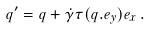Convert formula to latex. <formula><loc_0><loc_0><loc_500><loc_500>q ^ { \prime } = q + \dot { \gamma } \tau ( q . e _ { y } ) e _ { x } \, .</formula> 